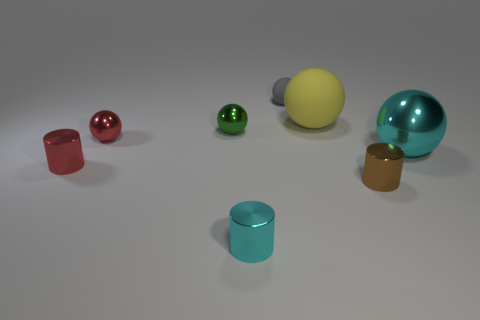Can you talk about the composition and balance of the image? The composition of the image is carefully balanced, with the objects arranged diagonally across the frame, which leads the viewer's eye through the picture. There is a harmonious distribution of shapes and colors, creating a visually appealing and organized scene. 